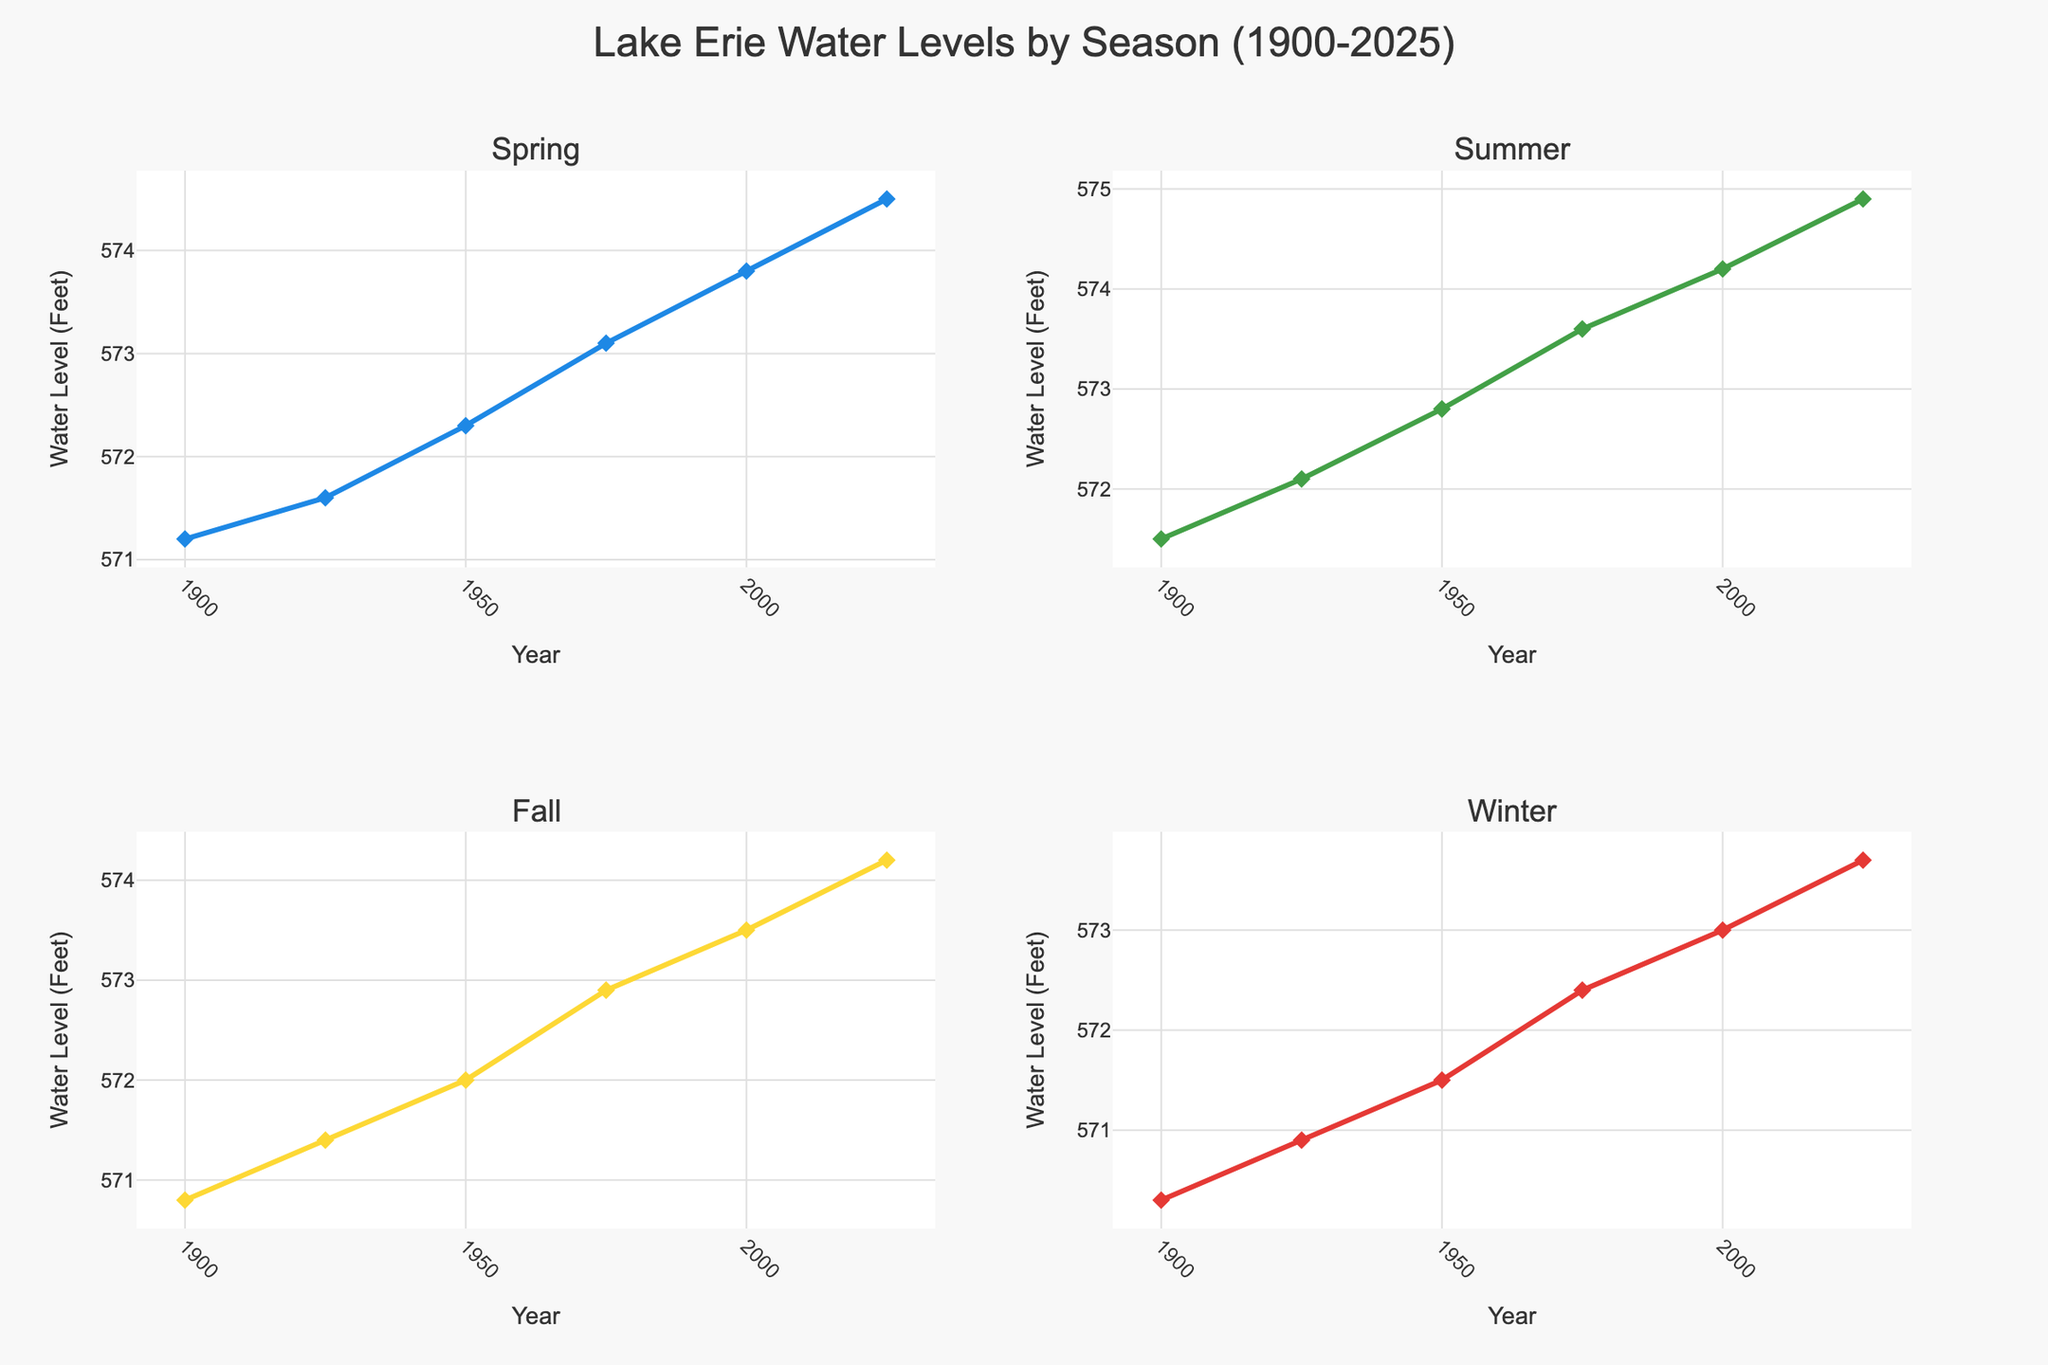How many seasons are displayed in the figure? The subplot titles indicate that there are four seasons shown: Spring, Summer, Fall, and Winter. The subplots are organized in a 2x2 grid.
Answer: Four What is the title of the subplot in the bottom-left corner? The titles of the subplots correspond to the seasons, and the bottom-left corner shows data for Fall.
Answer: Fall Which season has the highest water level in the year 2025? Looking at the lines and markers for the year 2025 across all subplots, Summer has the highest water level at 574.9 feet.
Answer: Summer During which season did the water level first reach above 573 feet? Examining the subplots in each season and the corresponding years, the Spring season in 1975 is the first to show water levels above 573 feet at 573.1.
Answer: Spring By how many feet did the water level in Summer increase from 1900 to 2025? The water level in Summer 1900 is 571.5 feet and in 2025 is 574.9 feet. The increase is 574.9 - 571.5 = 3.4 feet.
Answer: 3.4 feet Is the water level trend increasing, decreasing, or stable during the Winter season from 1900 to 2025? Observing the Winter subplot, the water level is steadily increasing over the years from 570.3 feet in 1900 to 573.7 feet in 2025.
Answer: Increasing What is the average water level in the Fall season over the data points provided? The water levels for Fall are 570.8, 571.4, 572.0, 572.9, 573.5, and 574.2. The average is (570.8 + 571.4 + 572.0 + 572.9 + 573.5 + 574.2) / 6 = 572.3 feet.
Answer: 572.3 feet Which season has the most significant difference in water level from 1900 to 2000? Calculating the difference from 1900 to 2000 for each season: Spring (573.8 - 571.2 = 2.6), Summer (574.2 - 571.5 = 2.7), Fall (573.5 - 570.8 = 2.7), Winter (573.0 - 570.3 = 2.7). The differences are close, but Summer has the most significant difference at 2.7 feet.
Answer: Summer How does the water level in Spring 1950 compare to the water level in Spring 2000? The water level in Spring 1950 is 572.3 feet and in Spring 2000 is 573.8 feet, indicating an increase of 1.5 feet over this period.
Answer: Increased by 1.5 feet 